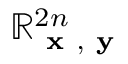<formula> <loc_0><loc_0><loc_500><loc_500>\mathbb { R } _ { { x } , { y } } ^ { 2 n }</formula> 